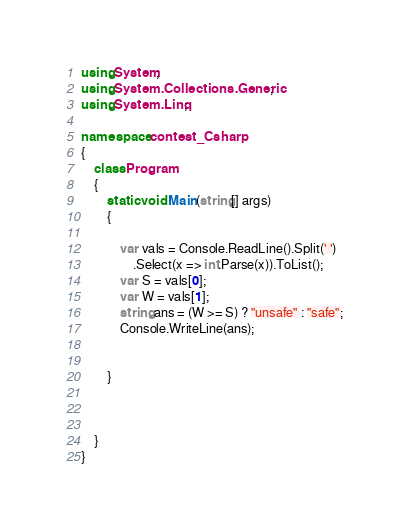<code> <loc_0><loc_0><loc_500><loc_500><_C#_>using System;
using System.Collections.Generic;
using System.Linq;

namespace contest_Csharp
{
    class Program
    {
        static void Main(string[] args)
        {

            var vals = Console.ReadLine().Split(' ')
                .Select(x => int.Parse(x)).ToList();
            var S = vals[0];
            var W = vals[1];
            string ans = (W >= S) ? "unsafe" : "safe";
            Console.WriteLine(ans);


        }
       
       

    }
}
</code> 